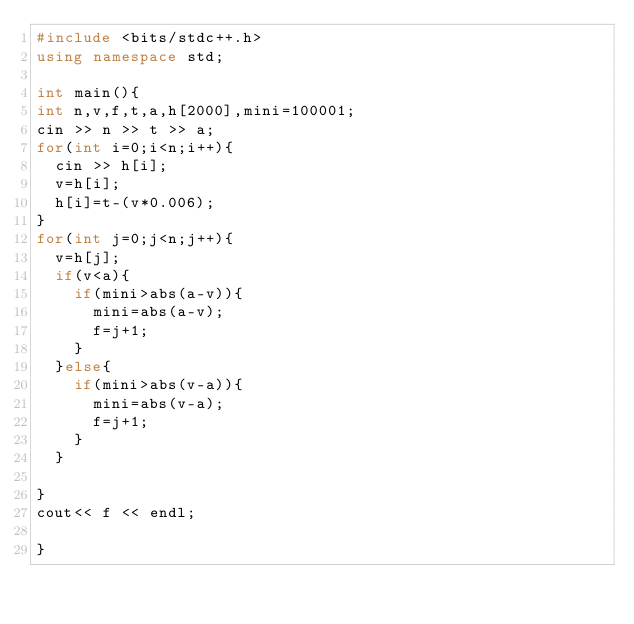<code> <loc_0><loc_0><loc_500><loc_500><_C++_>#include <bits/stdc++.h>
using namespace std;

int main(){
int n,v,f,t,a,h[2000],mini=100001;
cin >> n >> t >> a;
for(int i=0;i<n;i++){
  cin >> h[i];
  v=h[i];
  h[i]=t-(v*0.006);
}
for(int j=0;j<n;j++){
  v=h[j];
  if(v<a){
    if(mini>abs(a-v)){
      mini=abs(a-v);
      f=j+1;
    }
  }else{
    if(mini>abs(v-a)){
      mini=abs(v-a);
      f=j+1;
    }
  }

}
cout<< f << endl;

}
</code> 